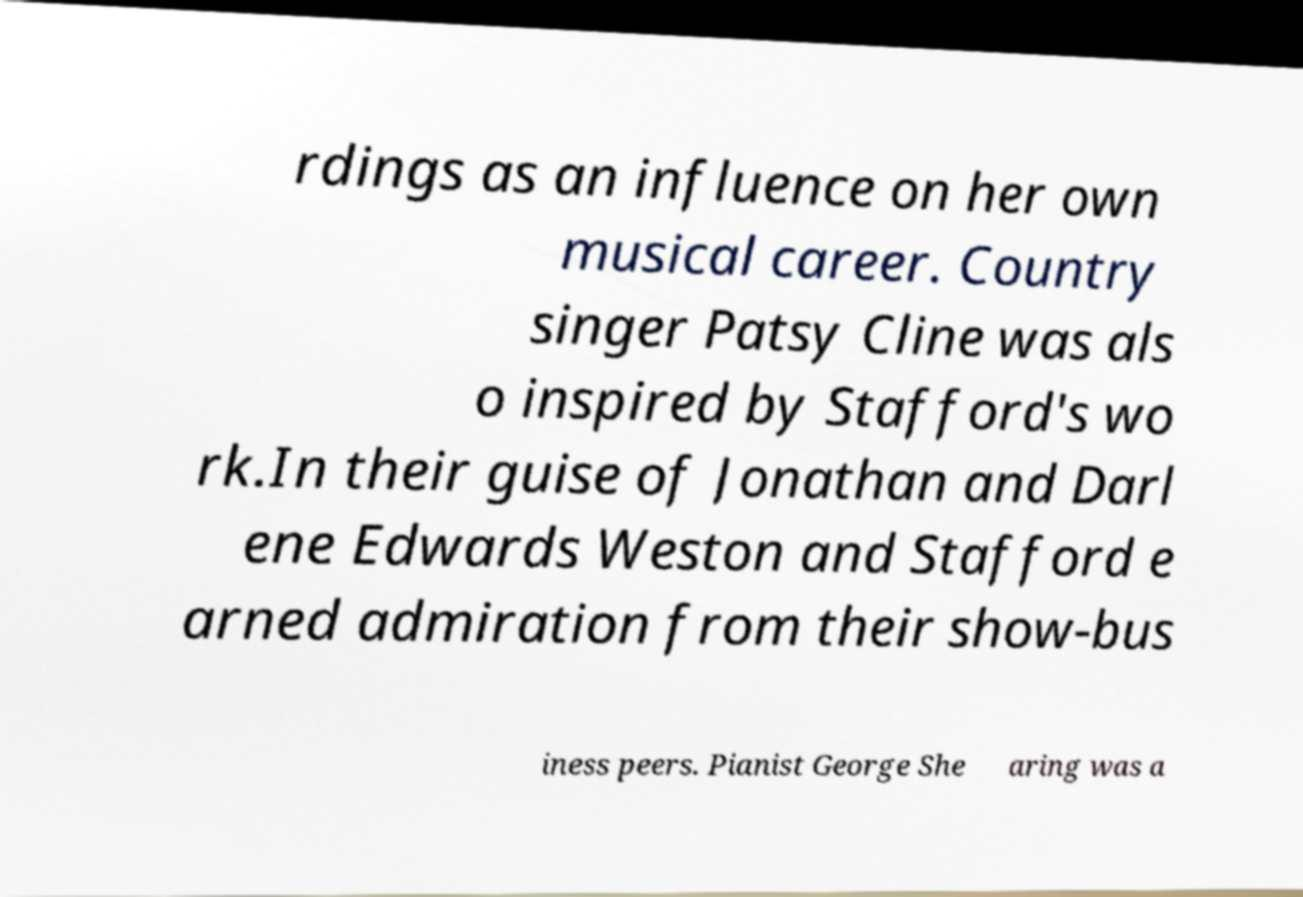Please identify and transcribe the text found in this image. rdings as an influence on her own musical career. Country singer Patsy Cline was als o inspired by Stafford's wo rk.In their guise of Jonathan and Darl ene Edwards Weston and Stafford e arned admiration from their show-bus iness peers. Pianist George She aring was a 